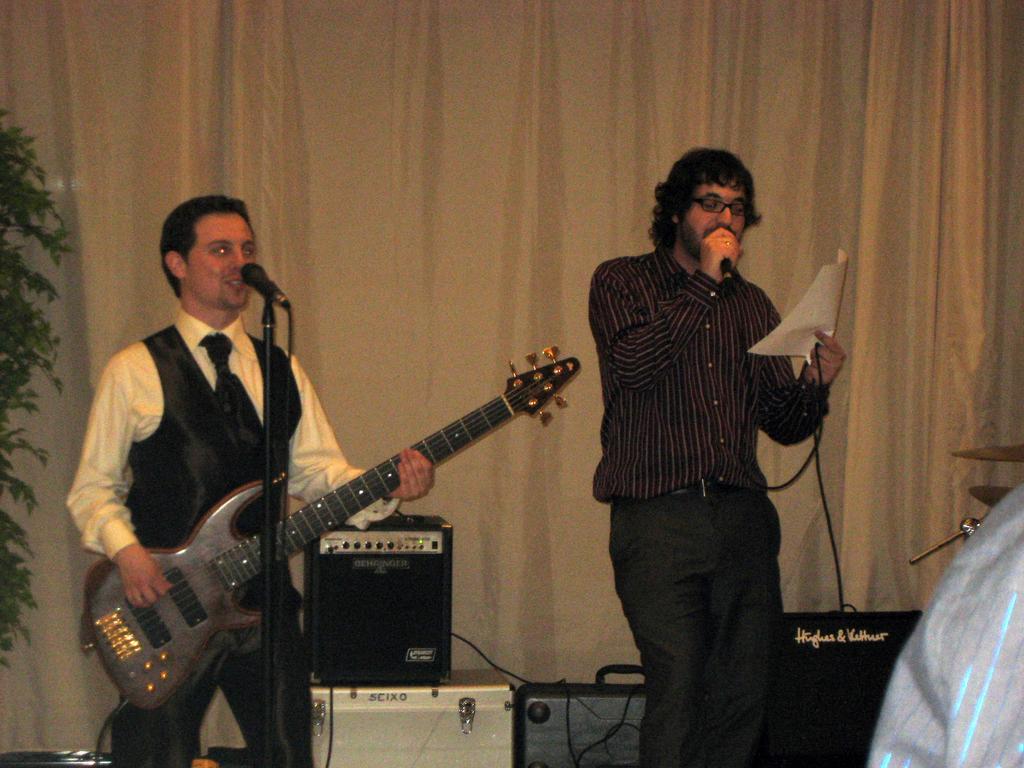Describe this image in one or two sentences. In this image I can see a person wearing black color dress is standing and holding a microphone and a paper in his hand. I can see another person wearing black and white colored dress is standing and holding a guitar. I can see a microphone in front of him. In the background I can see the cream colored curtain, a tree and some equipment. 